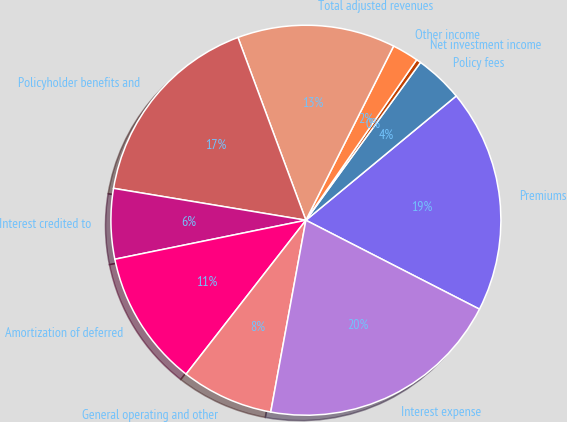Convert chart to OTSL. <chart><loc_0><loc_0><loc_500><loc_500><pie_chart><fcel>Premiums<fcel>Policy fees<fcel>Net investment income<fcel>Other income<fcel>Total adjusted revenues<fcel>Policyholder benefits and<fcel>Interest credited to<fcel>Amortization of deferred<fcel>General operating and other<fcel>Interest expense<nl><fcel>18.53%<fcel>4.01%<fcel>0.38%<fcel>2.19%<fcel>13.09%<fcel>16.72%<fcel>5.82%<fcel>11.27%<fcel>7.64%<fcel>20.35%<nl></chart> 